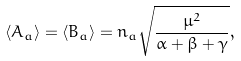Convert formula to latex. <formula><loc_0><loc_0><loc_500><loc_500>\langle A _ { a } \rangle = \langle B _ { a } \rangle = n _ { a } \sqrt { \frac { \mu ^ { 2 } } { \alpha + \beta + \gamma } } ,</formula> 